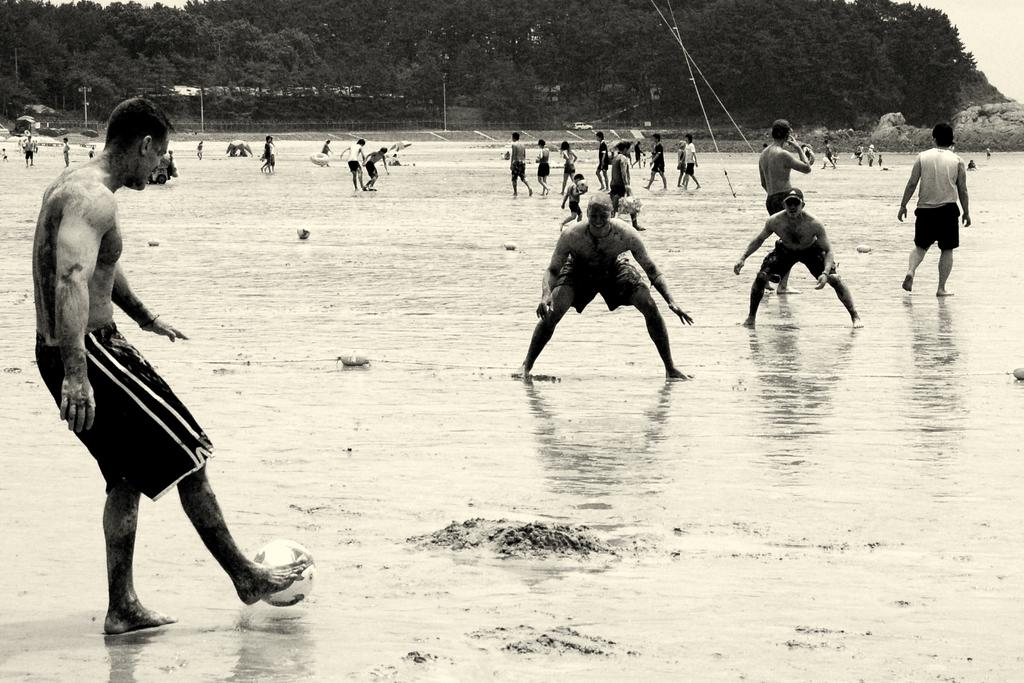What activity are the people in the image engaged in? The people in the image are playing football. What color is the football? The football is white. What is the condition of the ground in the image? There is water on the ground. What can be seen in the background of the image? There are green trees in the background of the image. Can you see a river flowing in the background of the image? No, there is no river visible in the image. Is there an airplane flying over the football players in the image? No, there is no airplane present in the image. 